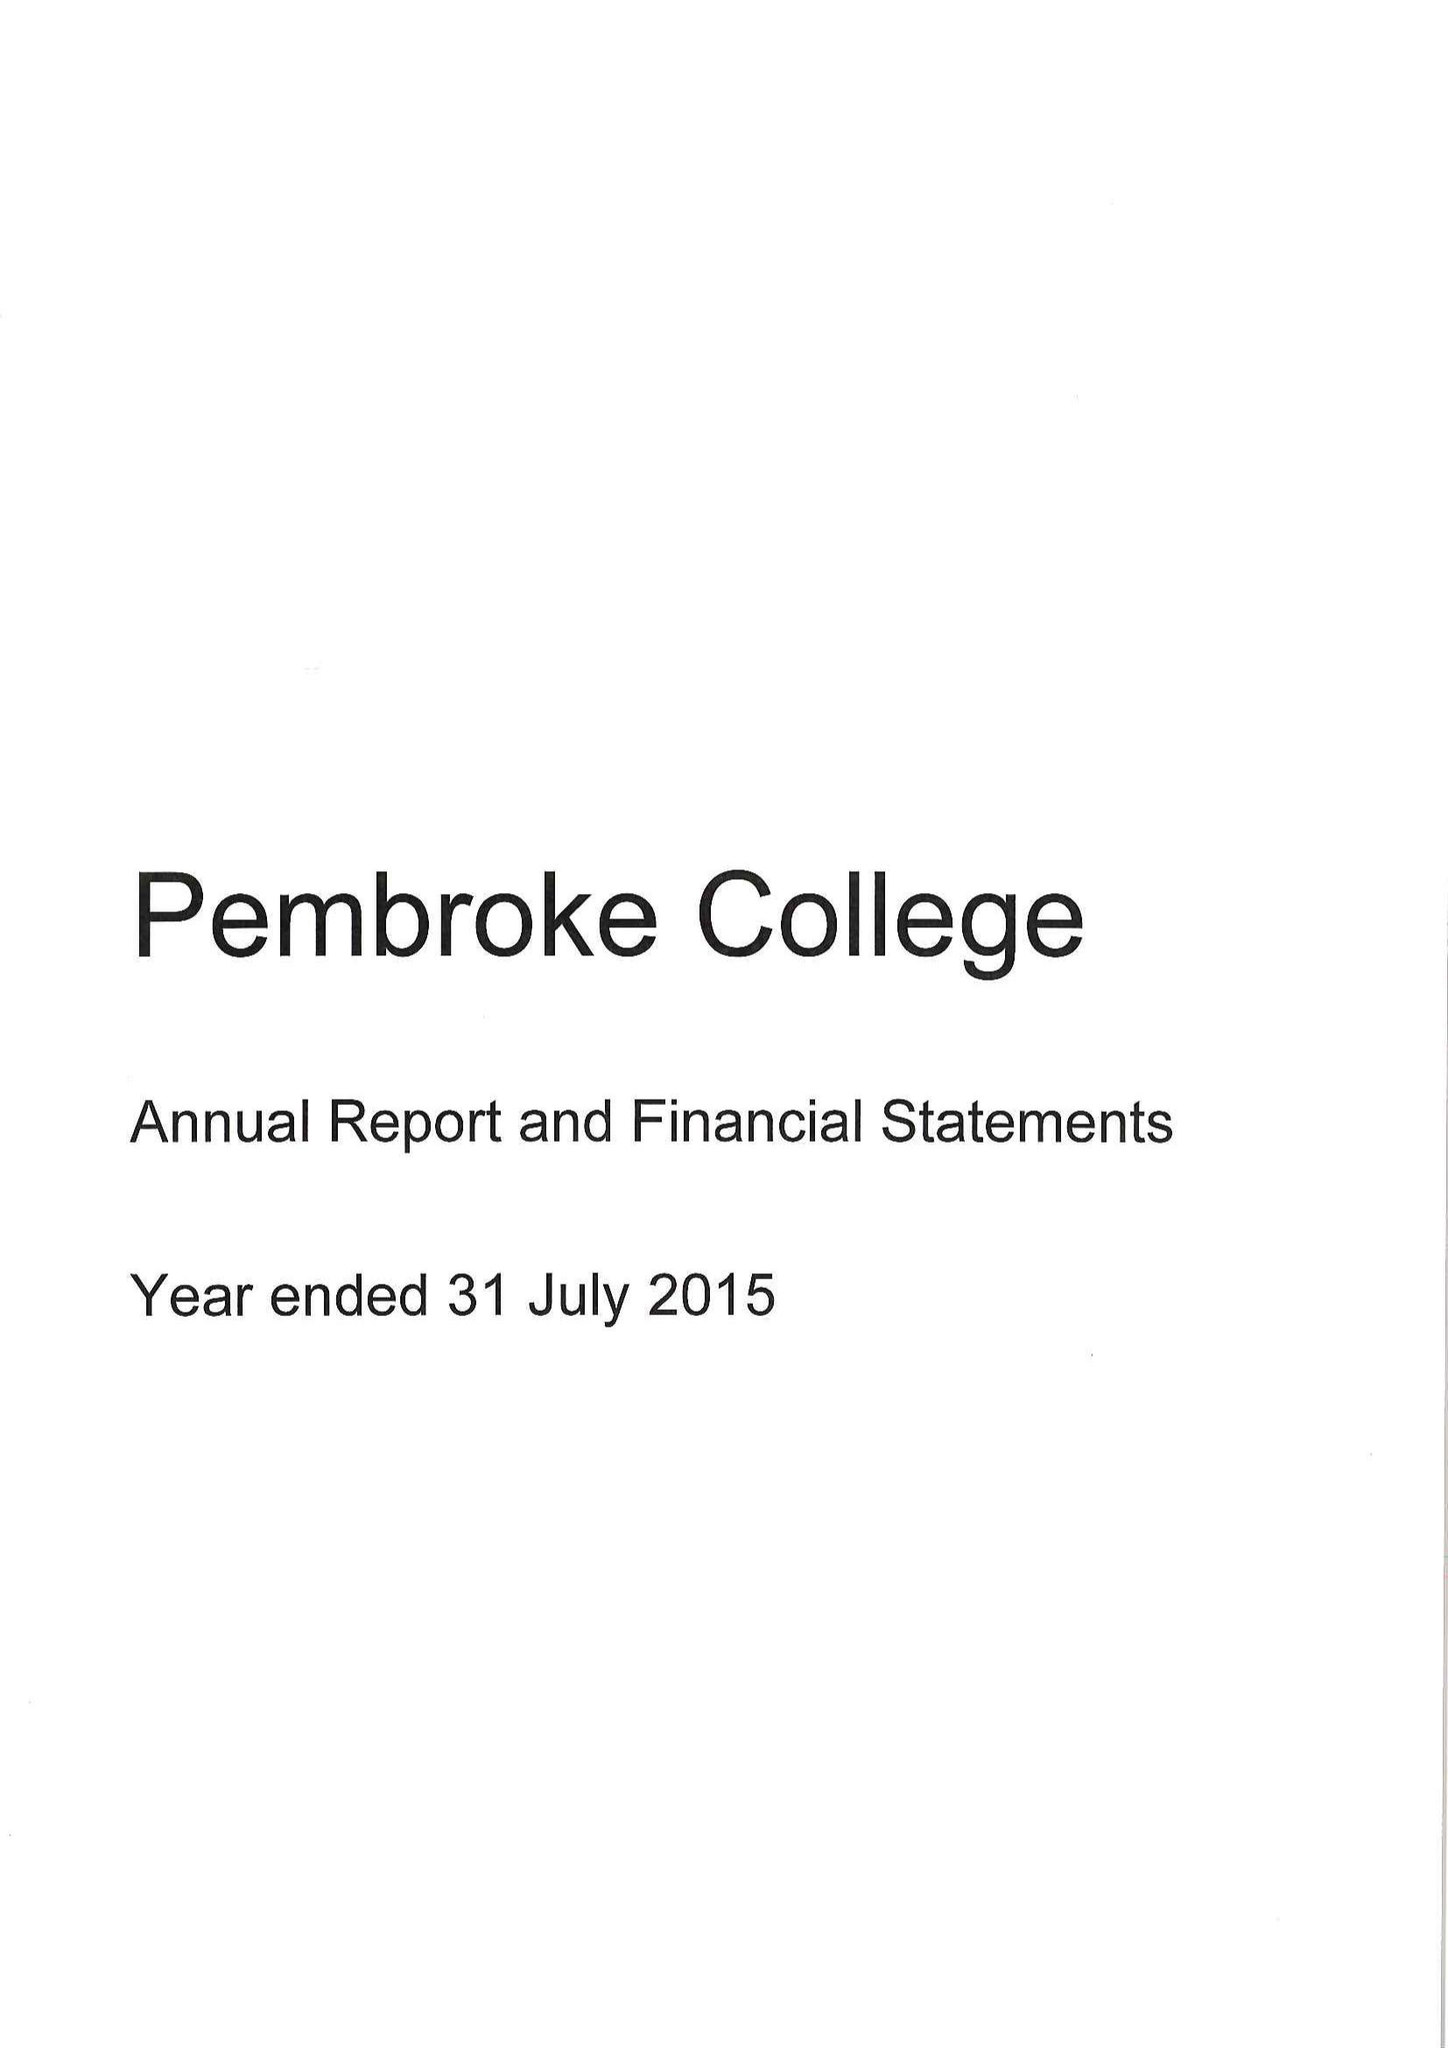What is the value for the report_date?
Answer the question using a single word or phrase. 2015-07-31 